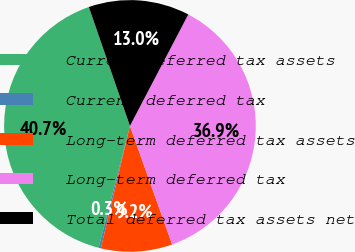<chart> <loc_0><loc_0><loc_500><loc_500><pie_chart><fcel>Current deferred tax assets<fcel>Current deferred tax<fcel>Long-term deferred tax assets<fcel>Long-term deferred tax<fcel>Total deferred tax assets net<nl><fcel>40.69%<fcel>0.29%<fcel>9.16%<fcel>36.88%<fcel>12.97%<nl></chart> 